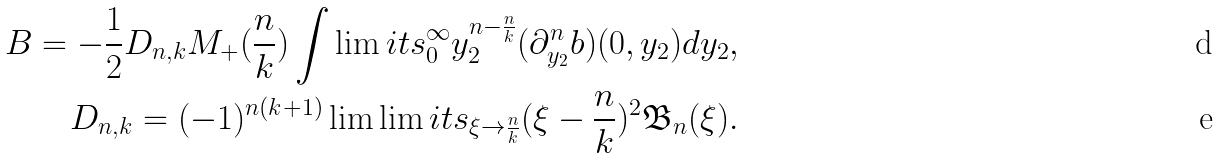Convert formula to latex. <formula><loc_0><loc_0><loc_500><loc_500>B = - \frac { 1 } { 2 } D _ { n , k } M _ { + } ( \frac { n } { k } ) \int \lim i t s _ { 0 } ^ { \infty } y _ { 2 } ^ { n - \frac { n } { k } } ( \partial ^ { n } _ { y _ { 2 } } b ) ( 0 , y _ { 2 } ) d y _ { 2 } , \\ D _ { n , k } = ( - 1 ) ^ { n ( k + 1 ) } \lim \lim i t s _ { \xi \rightarrow \frac { n } { k } } ( \xi - \frac { n } { k } ) ^ { 2 } \mathfrak { B } _ { n } ( \xi ) .</formula> 